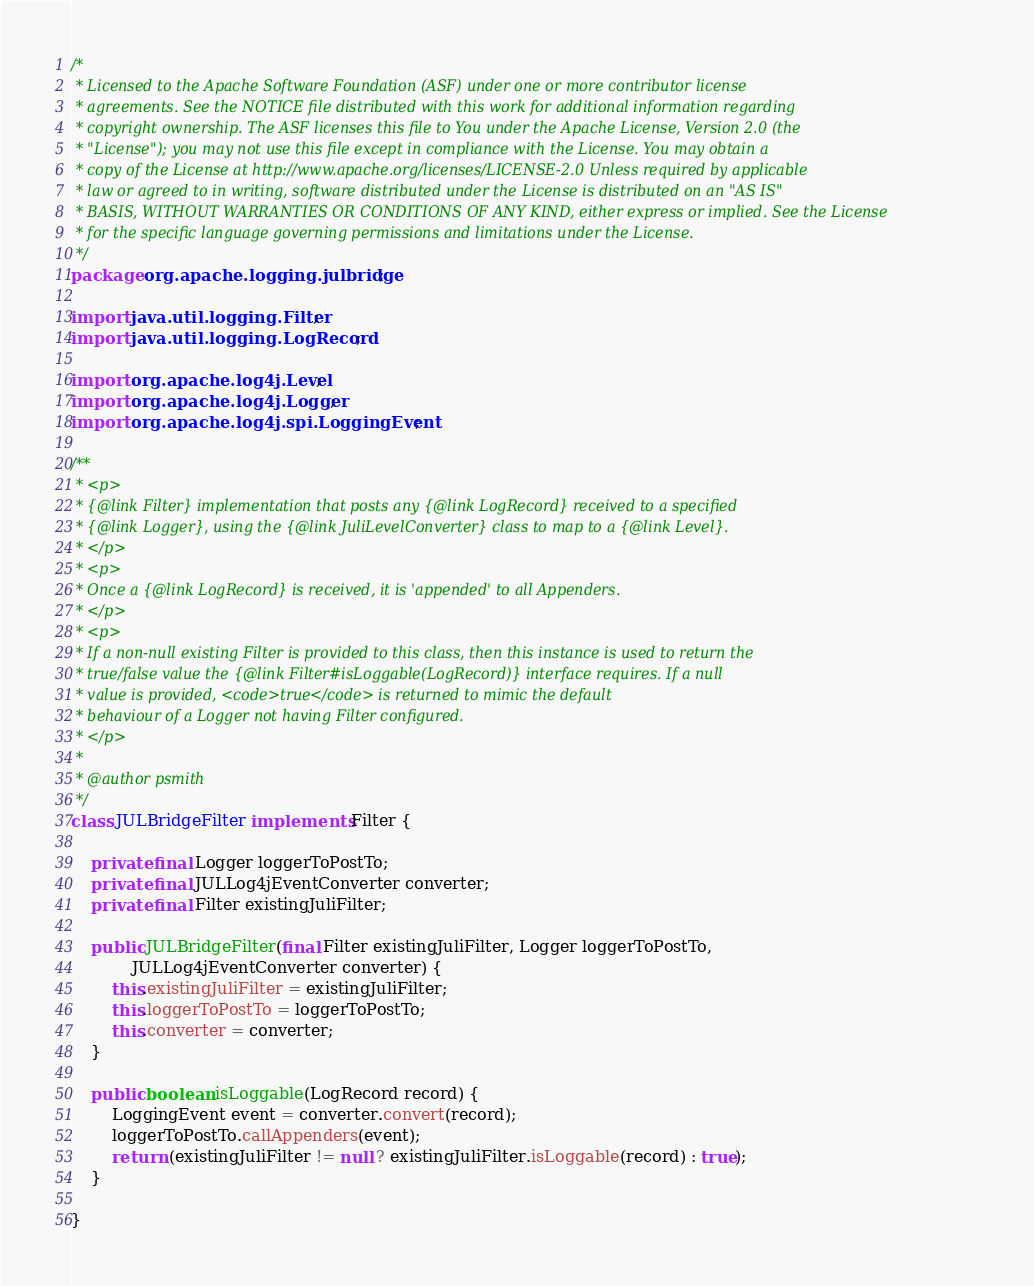<code> <loc_0><loc_0><loc_500><loc_500><_Java_>/*
 * Licensed to the Apache Software Foundation (ASF) under one or more contributor license
 * agreements. See the NOTICE file distributed with this work for additional information regarding
 * copyright ownership. The ASF licenses this file to You under the Apache License, Version 2.0 (the
 * "License"); you may not use this file except in compliance with the License. You may obtain a
 * copy of the License at http://www.apache.org/licenses/LICENSE-2.0 Unless required by applicable
 * law or agreed to in writing, software distributed under the License is distributed on an "AS IS"
 * BASIS, WITHOUT WARRANTIES OR CONDITIONS OF ANY KIND, either express or implied. See the License
 * for the specific language governing permissions and limitations under the License.
 */
package org.apache.logging.julbridge;

import java.util.logging.Filter;
import java.util.logging.LogRecord;

import org.apache.log4j.Level;
import org.apache.log4j.Logger;
import org.apache.log4j.spi.LoggingEvent;

/**
 * <p>
 * {@link Filter} implementation that posts any {@link LogRecord} received to a specified
 * {@link Logger}, using the {@link JuliLevelConverter} class to map to a {@link Level}.
 * </p>
 * <p>
 * Once a {@link LogRecord} is received, it is 'appended' to all Appenders.
 * </p>
 * <p>
 * If a non-null existing Filter is provided to this class, then this instance is used to return the
 * true/false value the {@link Filter#isLoggable(LogRecord)} interface requires. If a null
 * value is provided, <code>true</code> is returned to mimic the default
 * behaviour of a Logger not having Filter configured.
 * </p>
 * 
 * @author psmith
 */
class JULBridgeFilter implements Filter {

    private final Logger loggerToPostTo;
    private final JULLog4jEventConverter converter;
    private final Filter existingJuliFilter;

    public JULBridgeFilter(final Filter existingJuliFilter, Logger loggerToPostTo,
            JULLog4jEventConverter converter) {
        this.existingJuliFilter = existingJuliFilter;
        this.loggerToPostTo = loggerToPostTo;
        this.converter = converter;
    }

    public boolean isLoggable(LogRecord record) {
        LoggingEvent event = converter.convert(record);
        loggerToPostTo.callAppenders(event);
        return (existingJuliFilter != null ? existingJuliFilter.isLoggable(record) : true);
    }

}
</code> 